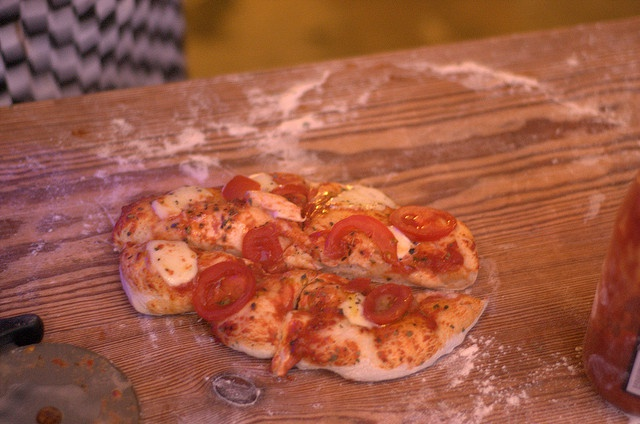Describe the objects in this image and their specific colors. I can see dining table in brown, purple, and maroon tones, pizza in purple, brown, red, and salmon tones, and bottle in purple, maroon, brown, and black tones in this image. 